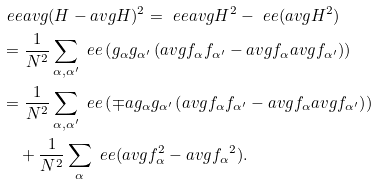Convert formula to latex. <formula><loc_0><loc_0><loc_500><loc_500>& \ e e a v g { ( H - a v g { H } ) ^ { 2 } } = \ e e a v g { H ^ { 2 } } - \ e e ( a v g { H } ^ { 2 } ) \\ & = \frac { 1 } { N ^ { 2 } } \sum _ { \alpha , \alpha ^ { \prime } } \ e e \left ( g _ { \alpha } g _ { \alpha ^ { \prime } } \left ( a v g { f _ { \alpha } f _ { \alpha ^ { \prime } } } - a v g { f _ { \alpha } } a v g { f _ { \alpha ^ { \prime } } } \right ) \right ) \\ & = \frac { 1 } { N ^ { 2 } } \sum _ { \alpha , \alpha ^ { \prime } } \ e e \left ( \mp a { g _ { \alpha } } { g _ { \alpha ^ { \prime } } } \left ( a v g { f _ { \alpha } f _ { \alpha ^ { \prime } } } - a v g { f _ { \alpha } } a v g { f _ { \alpha ^ { \prime } } } \right ) \right ) \\ & \quad + \frac { 1 } { N ^ { 2 } } \sum _ { \alpha } \ e e ( a v g { f _ { \alpha } ^ { 2 } } - a v g { f _ { \alpha } } ^ { 2 } ) .</formula> 